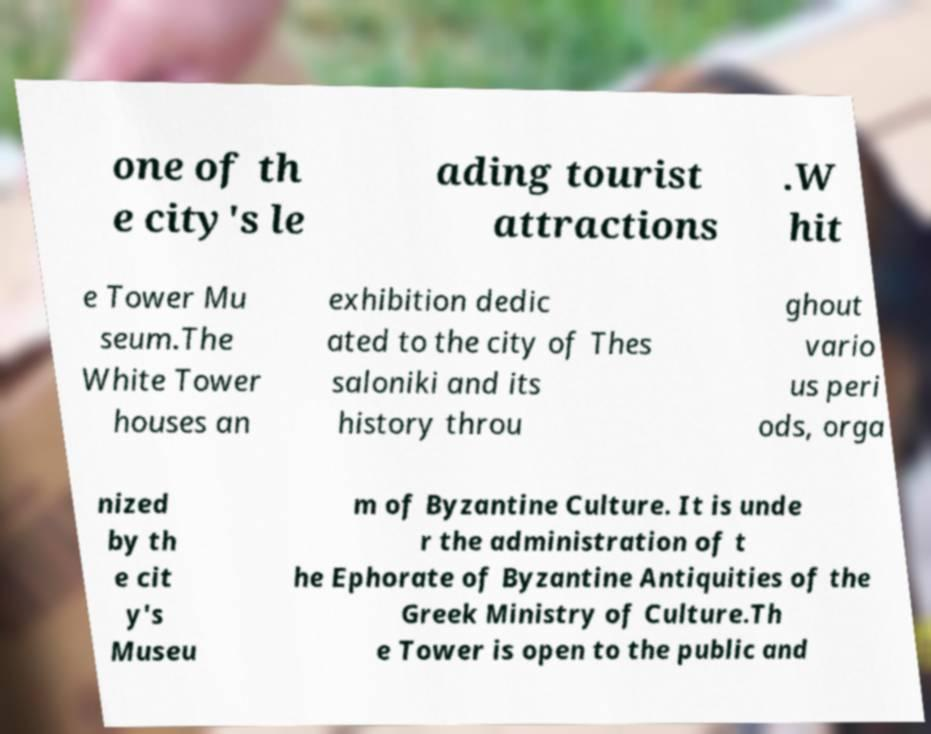Could you assist in decoding the text presented in this image and type it out clearly? one of th e city's le ading tourist attractions .W hit e Tower Mu seum.The White Tower houses an exhibition dedic ated to the city of Thes saloniki and its history throu ghout vario us peri ods, orga nized by th e cit y's Museu m of Byzantine Culture. It is unde r the administration of t he Ephorate of Byzantine Antiquities of the Greek Ministry of Culture.Th e Tower is open to the public and 